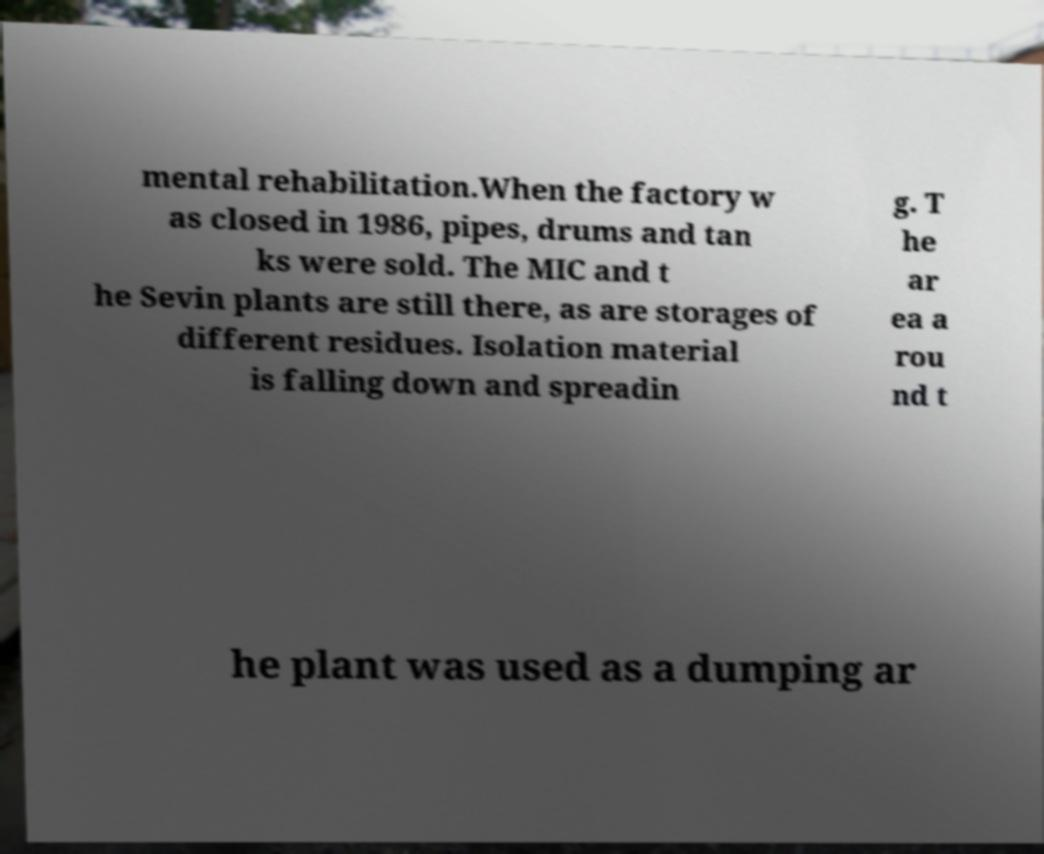Please read and relay the text visible in this image. What does it say? mental rehabilitation.When the factory w as closed in 1986, pipes, drums and tan ks were sold. The MIC and t he Sevin plants are still there, as are storages of different residues. Isolation material is falling down and spreadin g. T he ar ea a rou nd t he plant was used as a dumping ar 